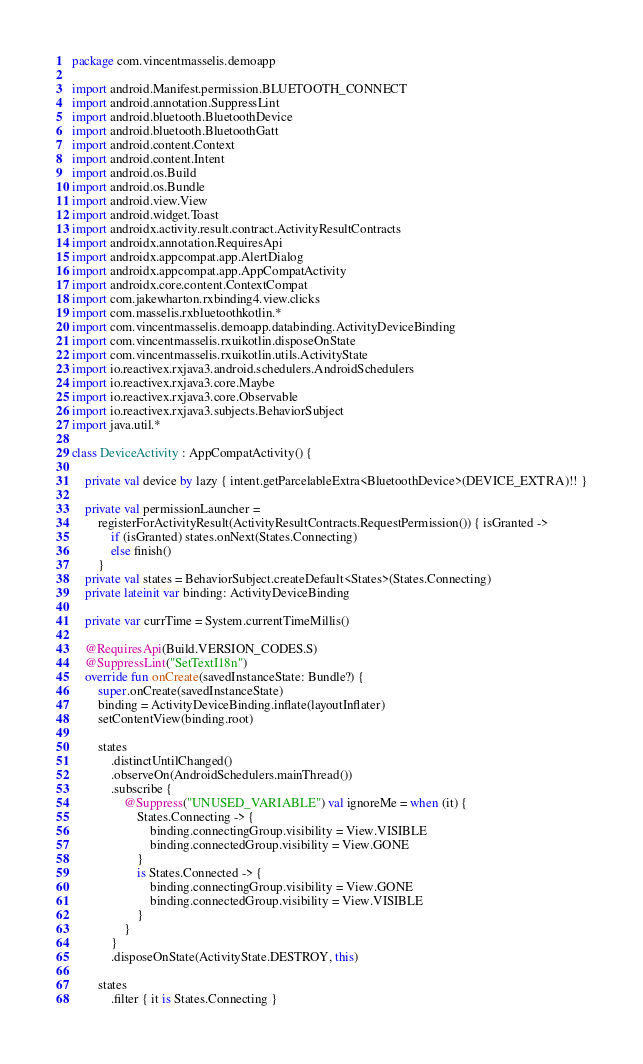Convert code to text. <code><loc_0><loc_0><loc_500><loc_500><_Kotlin_>package com.vincentmasselis.demoapp

import android.Manifest.permission.BLUETOOTH_CONNECT
import android.annotation.SuppressLint
import android.bluetooth.BluetoothDevice
import android.bluetooth.BluetoothGatt
import android.content.Context
import android.content.Intent
import android.os.Build
import android.os.Bundle
import android.view.View
import android.widget.Toast
import androidx.activity.result.contract.ActivityResultContracts
import androidx.annotation.RequiresApi
import androidx.appcompat.app.AlertDialog
import androidx.appcompat.app.AppCompatActivity
import androidx.core.content.ContextCompat
import com.jakewharton.rxbinding4.view.clicks
import com.masselis.rxbluetoothkotlin.*
import com.vincentmasselis.demoapp.databinding.ActivityDeviceBinding
import com.vincentmasselis.rxuikotlin.disposeOnState
import com.vincentmasselis.rxuikotlin.utils.ActivityState
import io.reactivex.rxjava3.android.schedulers.AndroidSchedulers
import io.reactivex.rxjava3.core.Maybe
import io.reactivex.rxjava3.core.Observable
import io.reactivex.rxjava3.subjects.BehaviorSubject
import java.util.*

class DeviceActivity : AppCompatActivity() {

    private val device by lazy { intent.getParcelableExtra<BluetoothDevice>(DEVICE_EXTRA)!! }

    private val permissionLauncher =
        registerForActivityResult(ActivityResultContracts.RequestPermission()) { isGranted ->
            if (isGranted) states.onNext(States.Connecting)
            else finish()
        }
    private val states = BehaviorSubject.createDefault<States>(States.Connecting)
    private lateinit var binding: ActivityDeviceBinding

    private var currTime = System.currentTimeMillis()

    @RequiresApi(Build.VERSION_CODES.S)
    @SuppressLint("SetTextI18n")
    override fun onCreate(savedInstanceState: Bundle?) {
        super.onCreate(savedInstanceState)
        binding = ActivityDeviceBinding.inflate(layoutInflater)
        setContentView(binding.root)

        states
            .distinctUntilChanged()
            .observeOn(AndroidSchedulers.mainThread())
            .subscribe {
                @Suppress("UNUSED_VARIABLE") val ignoreMe = when (it) {
                    States.Connecting -> {
                        binding.connectingGroup.visibility = View.VISIBLE
                        binding.connectedGroup.visibility = View.GONE
                    }
                    is States.Connected -> {
                        binding.connectingGroup.visibility = View.GONE
                        binding.connectedGroup.visibility = View.VISIBLE
                    }
                }
            }
            .disposeOnState(ActivityState.DESTROY, this)

        states
            .filter { it is States.Connecting }</code> 